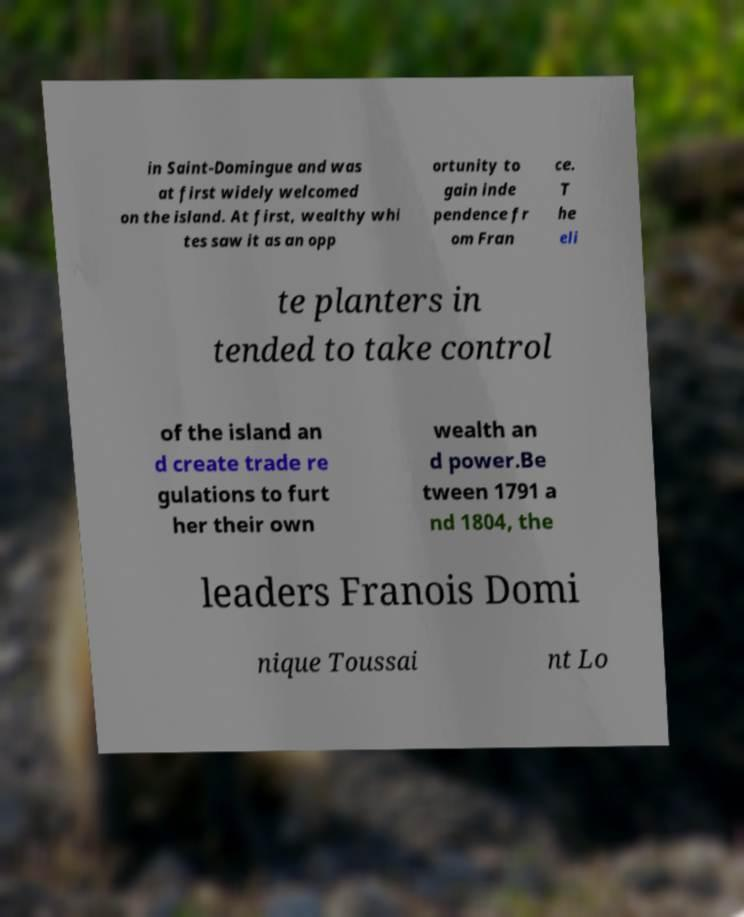Could you assist in decoding the text presented in this image and type it out clearly? in Saint-Domingue and was at first widely welcomed on the island. At first, wealthy whi tes saw it as an opp ortunity to gain inde pendence fr om Fran ce. T he eli te planters in tended to take control of the island an d create trade re gulations to furt her their own wealth an d power.Be tween 1791 a nd 1804, the leaders Franois Domi nique Toussai nt Lo 